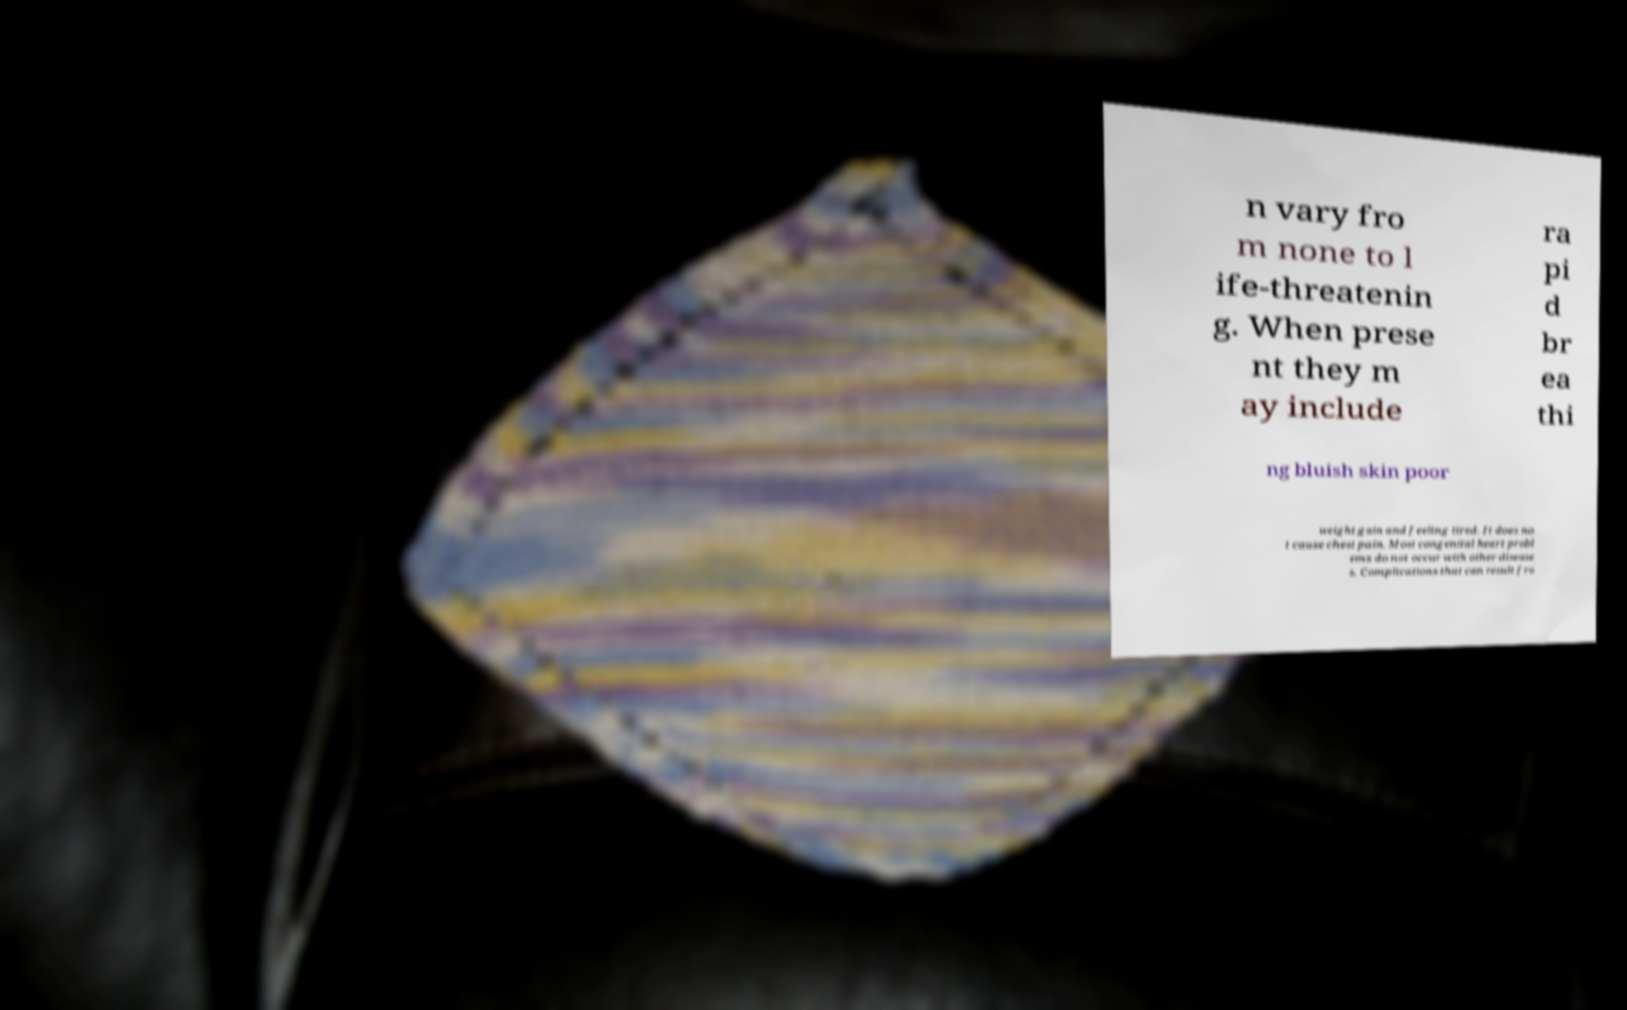There's text embedded in this image that I need extracted. Can you transcribe it verbatim? n vary fro m none to l ife-threatenin g. When prese nt they m ay include ra pi d br ea thi ng bluish skin poor weight gain and feeling tired. It does no t cause chest pain. Most congenital heart probl ems do not occur with other disease s. Complications that can result fro 